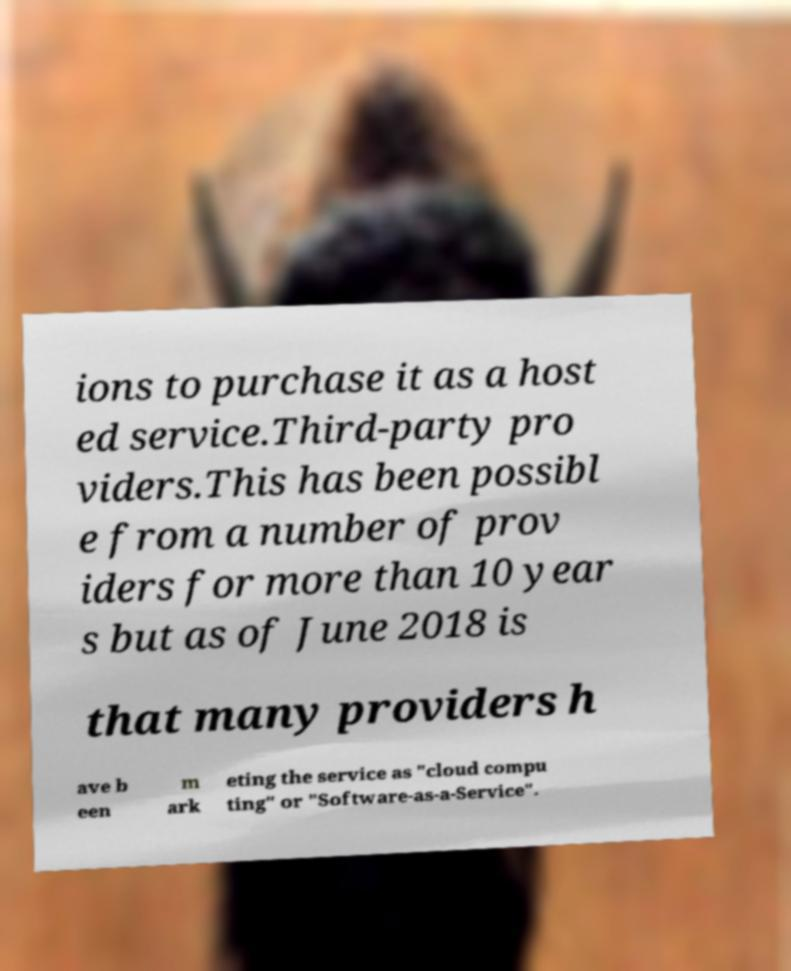Can you read and provide the text displayed in the image?This photo seems to have some interesting text. Can you extract and type it out for me? ions to purchase it as a host ed service.Third-party pro viders.This has been possibl e from a number of prov iders for more than 10 year s but as of June 2018 is that many providers h ave b een m ark eting the service as "cloud compu ting" or "Software-as-a-Service". 